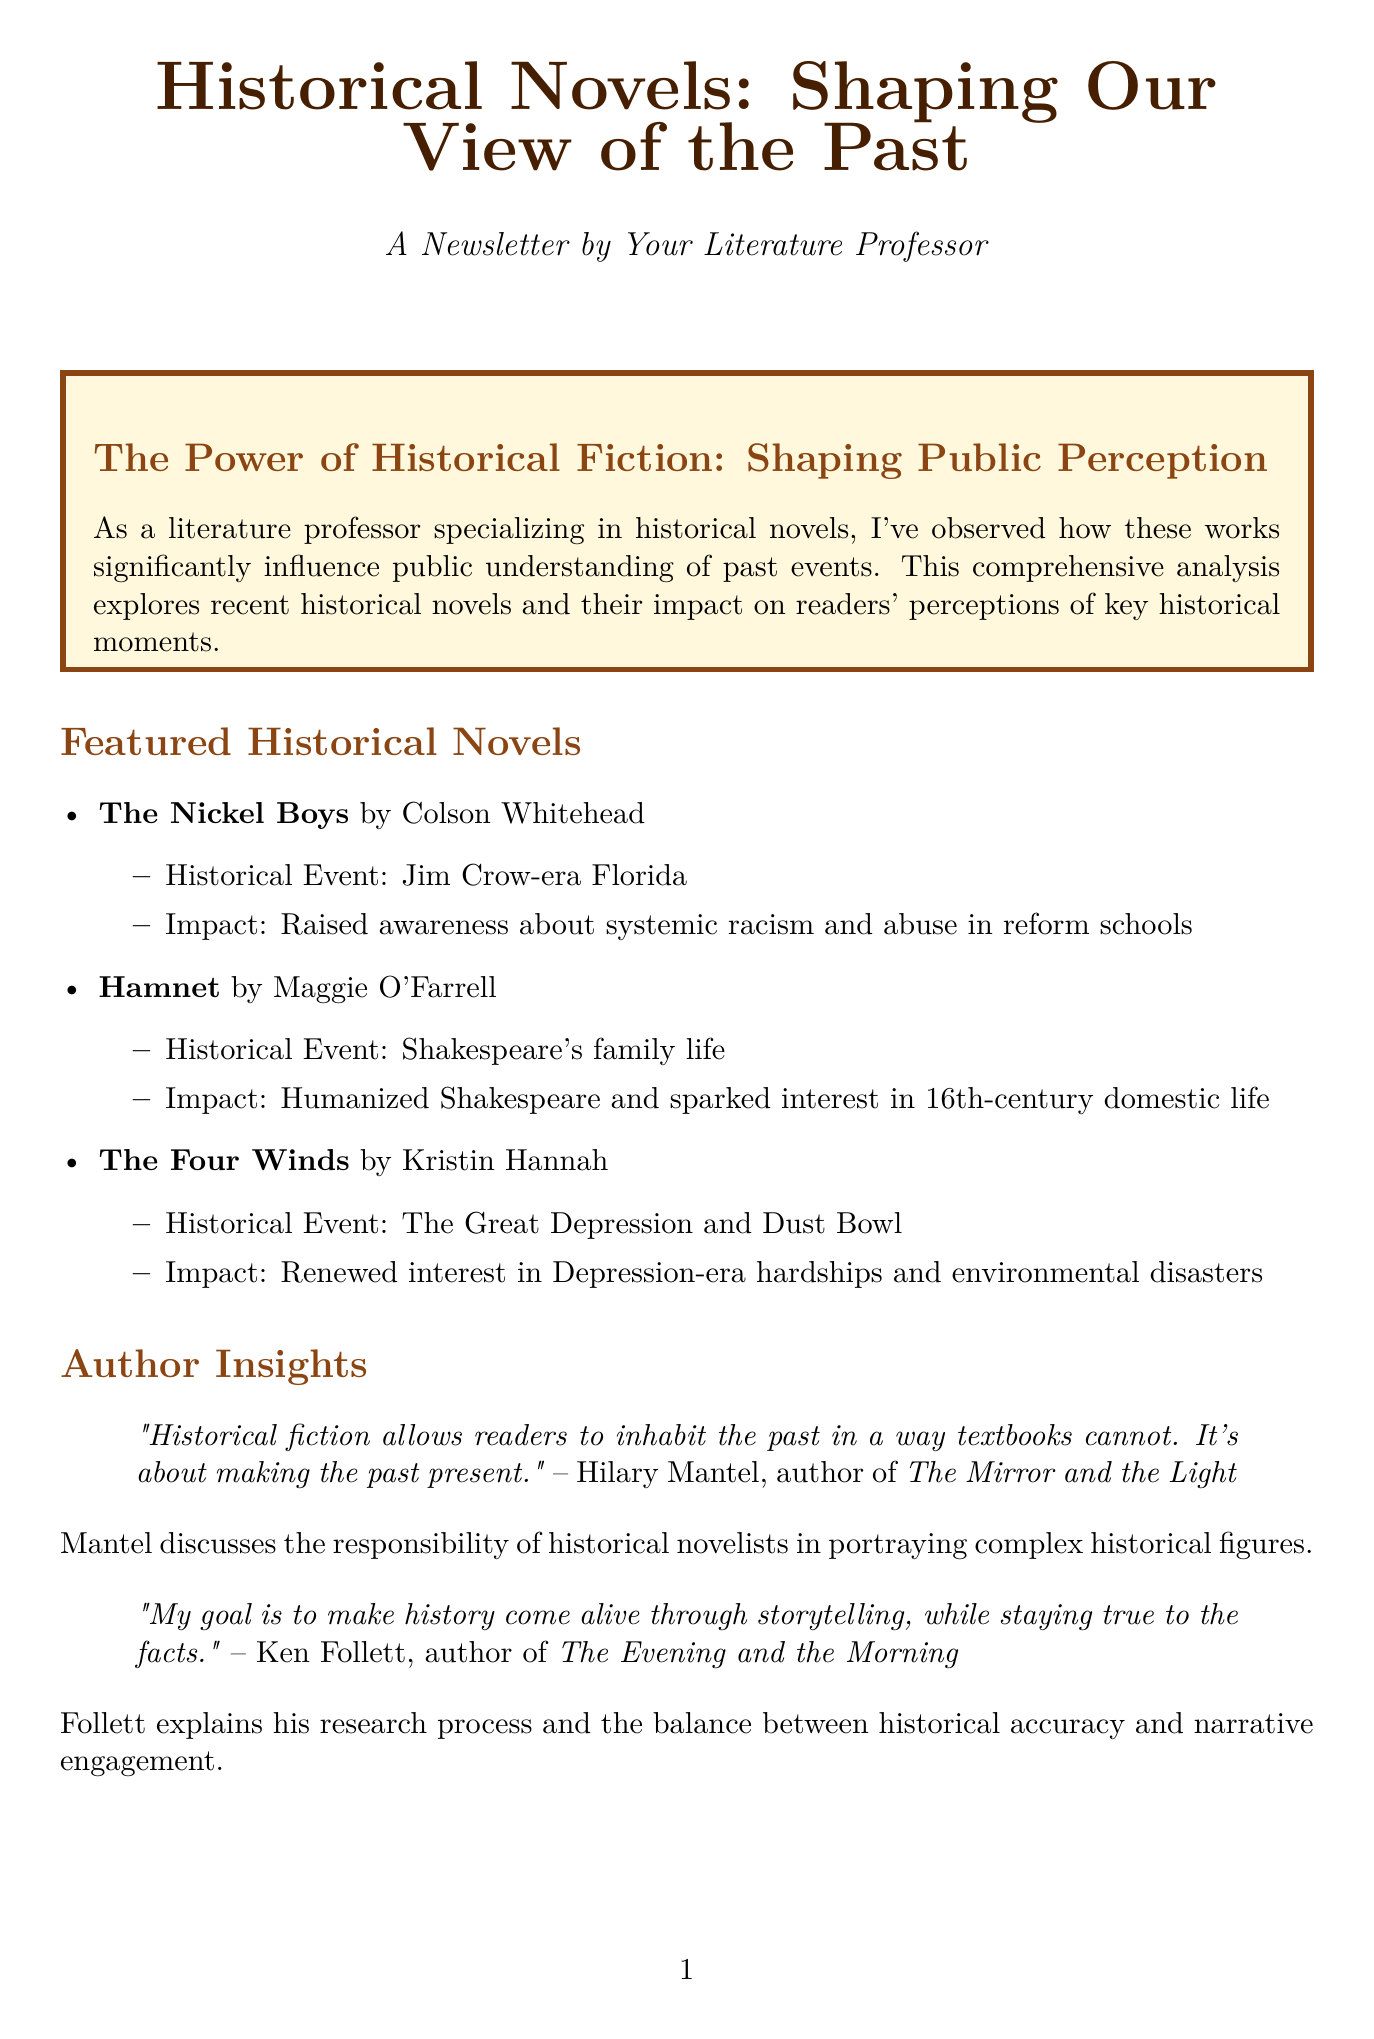What is the historical event in "The Nickel Boys"? "The Nickel Boys" focuses on systemic racism and abuse in reform schools during the Jim Crow-era in Florida.
Answer: Jim Crow-era Florida Who is the author of "Hamnet"? The document specifies Maggie O'Farrell as the author of "Hamnet."
Answer: Maggie O'Farrell What percentage of readers felt more emotionally connected to historical events after reading fictional accounts? The survey shows that 62% of readers reported feeling more connected to historical events.
Answer: 62% What is the name of the author interviewed about "The Mirror and the Light"? Hilary Mantel is the author who discussed her work "The Mirror and the Light."
Answer: Hilary Mantel What is a key responsibility of historical novelists according to Hilary Mantel? Mantel emphasizes the responsibility of novelists in portraying complex historical figures.
Answer: Portraying complex historical figures What percentage of survey participants reported learning new historical information? The document states that 73% of participants reported learning new historical information.
Answer: 73% What is the title of the June 2023 event mentioned in the newsletter? The June 2023 event is named "Historical Novel Society Conference."
Answer: Historical Novel Society Conference What does the academic perspective section highlight about historical fiction? It examines how historical fiction can ignite interest in history but also risks oversimplifying events.
Answer: Risks oversimplifying events What is the primary focus of the Reader Survey Results section? This section focuses on the percentage of readers' experiences and insights regarding historical novels.
Answer: Readers' experiences and insights 